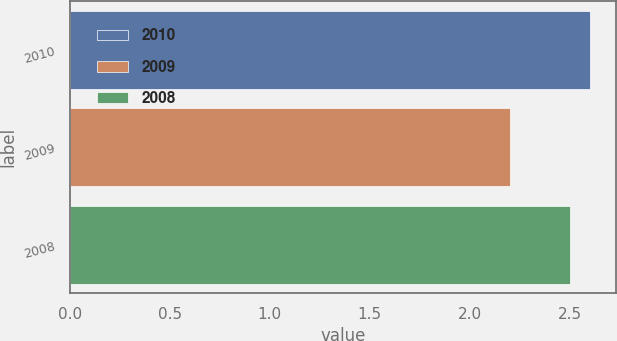Convert chart to OTSL. <chart><loc_0><loc_0><loc_500><loc_500><bar_chart><fcel>2010<fcel>2009<fcel>2008<nl><fcel>2.6<fcel>2.2<fcel>2.5<nl></chart> 